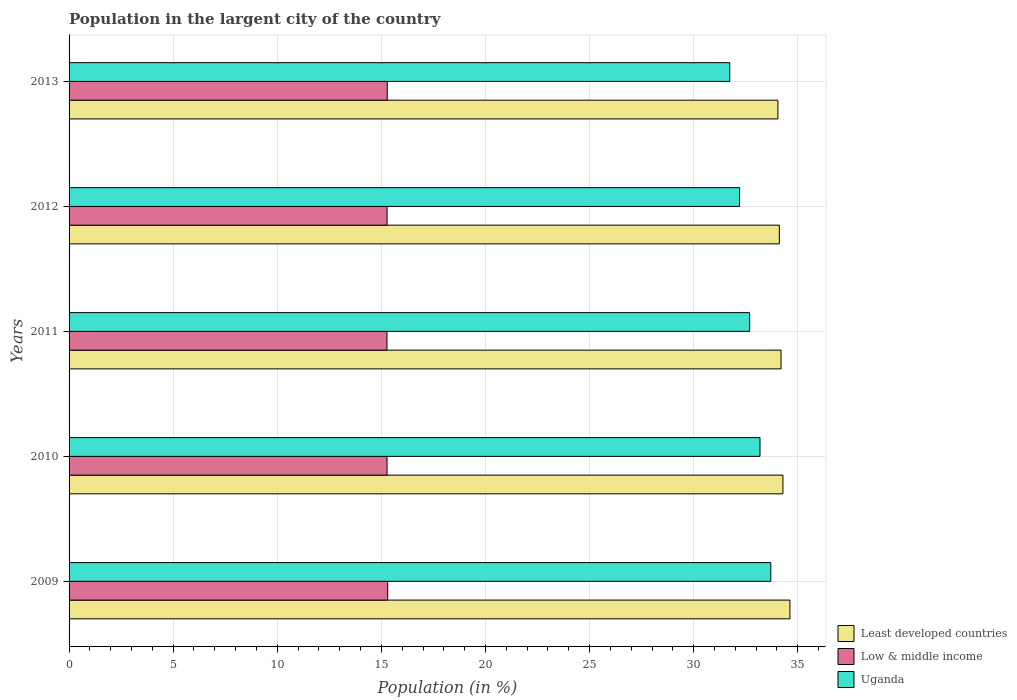How many groups of bars are there?
Offer a very short reply. 5. Are the number of bars per tick equal to the number of legend labels?
Offer a very short reply. Yes. How many bars are there on the 5th tick from the bottom?
Keep it short and to the point. 3. What is the percentage of population in the largent city in Uganda in 2011?
Provide a succinct answer. 32.69. Across all years, what is the maximum percentage of population in the largent city in Least developed countries?
Provide a succinct answer. 34.62. Across all years, what is the minimum percentage of population in the largent city in Uganda?
Ensure brevity in your answer.  31.73. In which year was the percentage of population in the largent city in Least developed countries minimum?
Your answer should be compact. 2013. What is the total percentage of population in the largent city in Least developed countries in the graph?
Your answer should be very brief. 171.27. What is the difference between the percentage of population in the largent city in Uganda in 2010 and that in 2011?
Provide a short and direct response. 0.5. What is the difference between the percentage of population in the largent city in Uganda in 2010 and the percentage of population in the largent city in Least developed countries in 2012?
Your answer should be compact. -0.93. What is the average percentage of population in the largent city in Uganda per year?
Provide a short and direct response. 32.7. In the year 2009, what is the difference between the percentage of population in the largent city in Uganda and percentage of population in the largent city in Least developed countries?
Offer a very short reply. -0.92. In how many years, is the percentage of population in the largent city in Least developed countries greater than 34 %?
Offer a terse response. 5. What is the ratio of the percentage of population in the largent city in Low & middle income in 2012 to that in 2013?
Provide a short and direct response. 1. What is the difference between the highest and the second highest percentage of population in the largent city in Uganda?
Ensure brevity in your answer.  0.52. What is the difference between the highest and the lowest percentage of population in the largent city in Least developed countries?
Give a very brief answer. 0.58. What does the 2nd bar from the top in 2010 represents?
Make the answer very short. Low & middle income. What does the 2nd bar from the bottom in 2011 represents?
Make the answer very short. Low & middle income. Is it the case that in every year, the sum of the percentage of population in the largent city in Low & middle income and percentage of population in the largent city in Uganda is greater than the percentage of population in the largent city in Least developed countries?
Your answer should be very brief. Yes. Are all the bars in the graph horizontal?
Your response must be concise. Yes. What is the difference between two consecutive major ticks on the X-axis?
Your response must be concise. 5. Are the values on the major ticks of X-axis written in scientific E-notation?
Make the answer very short. No. Does the graph contain grids?
Ensure brevity in your answer.  Yes. How many legend labels are there?
Provide a short and direct response. 3. How are the legend labels stacked?
Your response must be concise. Vertical. What is the title of the graph?
Ensure brevity in your answer.  Population in the largent city of the country. Does "Gambia, The" appear as one of the legend labels in the graph?
Your answer should be compact. No. What is the label or title of the Y-axis?
Make the answer very short. Years. What is the Population (in %) of Least developed countries in 2009?
Your answer should be compact. 34.62. What is the Population (in %) in Low & middle income in 2009?
Your answer should be very brief. 15.31. What is the Population (in %) of Uganda in 2009?
Offer a terse response. 33.71. What is the Population (in %) in Least developed countries in 2010?
Provide a succinct answer. 34.29. What is the Population (in %) of Low & middle income in 2010?
Offer a terse response. 15.27. What is the Population (in %) of Uganda in 2010?
Provide a succinct answer. 33.19. What is the Population (in %) in Least developed countries in 2011?
Your answer should be compact. 34.2. What is the Population (in %) of Low & middle income in 2011?
Your answer should be compact. 15.27. What is the Population (in %) of Uganda in 2011?
Make the answer very short. 32.69. What is the Population (in %) in Least developed countries in 2012?
Your response must be concise. 34.12. What is the Population (in %) in Low & middle income in 2012?
Ensure brevity in your answer.  15.27. What is the Population (in %) in Uganda in 2012?
Make the answer very short. 32.21. What is the Population (in %) in Least developed countries in 2013?
Your answer should be very brief. 34.05. What is the Population (in %) in Low & middle income in 2013?
Your response must be concise. 15.28. What is the Population (in %) in Uganda in 2013?
Make the answer very short. 31.73. Across all years, what is the maximum Population (in %) in Least developed countries?
Offer a terse response. 34.62. Across all years, what is the maximum Population (in %) in Low & middle income?
Offer a terse response. 15.31. Across all years, what is the maximum Population (in %) in Uganda?
Provide a succinct answer. 33.71. Across all years, what is the minimum Population (in %) in Least developed countries?
Your answer should be compact. 34.05. Across all years, what is the minimum Population (in %) of Low & middle income?
Ensure brevity in your answer.  15.27. Across all years, what is the minimum Population (in %) of Uganda?
Give a very brief answer. 31.73. What is the total Population (in %) in Least developed countries in the graph?
Your answer should be compact. 171.27. What is the total Population (in %) of Low & middle income in the graph?
Provide a succinct answer. 76.4. What is the total Population (in %) in Uganda in the graph?
Offer a terse response. 163.52. What is the difference between the Population (in %) of Least developed countries in 2009 and that in 2010?
Your answer should be very brief. 0.34. What is the difference between the Population (in %) of Low & middle income in 2009 and that in 2010?
Provide a short and direct response. 0.03. What is the difference between the Population (in %) in Uganda in 2009 and that in 2010?
Make the answer very short. 0.52. What is the difference between the Population (in %) in Least developed countries in 2009 and that in 2011?
Your answer should be very brief. 0.43. What is the difference between the Population (in %) in Low & middle income in 2009 and that in 2011?
Give a very brief answer. 0.04. What is the difference between the Population (in %) of Uganda in 2009 and that in 2011?
Offer a very short reply. 1.02. What is the difference between the Population (in %) of Least developed countries in 2009 and that in 2012?
Your answer should be very brief. 0.51. What is the difference between the Population (in %) of Low & middle income in 2009 and that in 2012?
Provide a short and direct response. 0.03. What is the difference between the Population (in %) in Uganda in 2009 and that in 2012?
Give a very brief answer. 1.5. What is the difference between the Population (in %) of Least developed countries in 2009 and that in 2013?
Your response must be concise. 0.58. What is the difference between the Population (in %) in Low & middle income in 2009 and that in 2013?
Your response must be concise. 0.02. What is the difference between the Population (in %) in Uganda in 2009 and that in 2013?
Provide a short and direct response. 1.97. What is the difference between the Population (in %) of Least developed countries in 2010 and that in 2011?
Offer a very short reply. 0.09. What is the difference between the Population (in %) in Low & middle income in 2010 and that in 2011?
Your answer should be very brief. 0. What is the difference between the Population (in %) in Uganda in 2010 and that in 2011?
Make the answer very short. 0.5. What is the difference between the Population (in %) of Least developed countries in 2010 and that in 2012?
Keep it short and to the point. 0.17. What is the difference between the Population (in %) in Low & middle income in 2010 and that in 2012?
Give a very brief answer. -0. What is the difference between the Population (in %) in Uganda in 2010 and that in 2012?
Keep it short and to the point. 0.98. What is the difference between the Population (in %) in Least developed countries in 2010 and that in 2013?
Provide a short and direct response. 0.24. What is the difference between the Population (in %) in Low & middle income in 2010 and that in 2013?
Ensure brevity in your answer.  -0.01. What is the difference between the Population (in %) of Uganda in 2010 and that in 2013?
Provide a short and direct response. 1.45. What is the difference between the Population (in %) in Least developed countries in 2011 and that in 2012?
Provide a succinct answer. 0.08. What is the difference between the Population (in %) in Low & middle income in 2011 and that in 2012?
Offer a very short reply. -0. What is the difference between the Population (in %) of Uganda in 2011 and that in 2012?
Ensure brevity in your answer.  0.48. What is the difference between the Population (in %) in Least developed countries in 2011 and that in 2013?
Your answer should be compact. 0.15. What is the difference between the Population (in %) of Low & middle income in 2011 and that in 2013?
Make the answer very short. -0.01. What is the difference between the Population (in %) in Uganda in 2011 and that in 2013?
Your answer should be very brief. 0.96. What is the difference between the Population (in %) in Least developed countries in 2012 and that in 2013?
Your response must be concise. 0.07. What is the difference between the Population (in %) of Low & middle income in 2012 and that in 2013?
Offer a very short reply. -0.01. What is the difference between the Population (in %) of Uganda in 2012 and that in 2013?
Your response must be concise. 0.47. What is the difference between the Population (in %) of Least developed countries in 2009 and the Population (in %) of Low & middle income in 2010?
Give a very brief answer. 19.35. What is the difference between the Population (in %) of Least developed countries in 2009 and the Population (in %) of Uganda in 2010?
Your response must be concise. 1.44. What is the difference between the Population (in %) in Low & middle income in 2009 and the Population (in %) in Uganda in 2010?
Provide a succinct answer. -17.88. What is the difference between the Population (in %) in Least developed countries in 2009 and the Population (in %) in Low & middle income in 2011?
Ensure brevity in your answer.  19.36. What is the difference between the Population (in %) in Least developed countries in 2009 and the Population (in %) in Uganda in 2011?
Provide a succinct answer. 1.94. What is the difference between the Population (in %) in Low & middle income in 2009 and the Population (in %) in Uganda in 2011?
Your response must be concise. -17.38. What is the difference between the Population (in %) of Least developed countries in 2009 and the Population (in %) of Low & middle income in 2012?
Offer a terse response. 19.35. What is the difference between the Population (in %) of Least developed countries in 2009 and the Population (in %) of Uganda in 2012?
Offer a terse response. 2.42. What is the difference between the Population (in %) of Low & middle income in 2009 and the Population (in %) of Uganda in 2012?
Offer a terse response. -16.9. What is the difference between the Population (in %) of Least developed countries in 2009 and the Population (in %) of Low & middle income in 2013?
Provide a succinct answer. 19.34. What is the difference between the Population (in %) of Least developed countries in 2009 and the Population (in %) of Uganda in 2013?
Offer a terse response. 2.89. What is the difference between the Population (in %) of Low & middle income in 2009 and the Population (in %) of Uganda in 2013?
Keep it short and to the point. -16.43. What is the difference between the Population (in %) in Least developed countries in 2010 and the Population (in %) in Low & middle income in 2011?
Offer a very short reply. 19.02. What is the difference between the Population (in %) in Least developed countries in 2010 and the Population (in %) in Uganda in 2011?
Give a very brief answer. 1.6. What is the difference between the Population (in %) in Low & middle income in 2010 and the Population (in %) in Uganda in 2011?
Provide a short and direct response. -17.42. What is the difference between the Population (in %) in Least developed countries in 2010 and the Population (in %) in Low & middle income in 2012?
Give a very brief answer. 19.02. What is the difference between the Population (in %) in Least developed countries in 2010 and the Population (in %) in Uganda in 2012?
Make the answer very short. 2.08. What is the difference between the Population (in %) in Low & middle income in 2010 and the Population (in %) in Uganda in 2012?
Offer a very short reply. -16.93. What is the difference between the Population (in %) in Least developed countries in 2010 and the Population (in %) in Low & middle income in 2013?
Provide a short and direct response. 19.01. What is the difference between the Population (in %) in Least developed countries in 2010 and the Population (in %) in Uganda in 2013?
Provide a short and direct response. 2.55. What is the difference between the Population (in %) of Low & middle income in 2010 and the Population (in %) of Uganda in 2013?
Keep it short and to the point. -16.46. What is the difference between the Population (in %) in Least developed countries in 2011 and the Population (in %) in Low & middle income in 2012?
Provide a succinct answer. 18.92. What is the difference between the Population (in %) of Least developed countries in 2011 and the Population (in %) of Uganda in 2012?
Keep it short and to the point. 1.99. What is the difference between the Population (in %) in Low & middle income in 2011 and the Population (in %) in Uganda in 2012?
Keep it short and to the point. -16.94. What is the difference between the Population (in %) of Least developed countries in 2011 and the Population (in %) of Low & middle income in 2013?
Make the answer very short. 18.91. What is the difference between the Population (in %) of Least developed countries in 2011 and the Population (in %) of Uganda in 2013?
Make the answer very short. 2.46. What is the difference between the Population (in %) of Low & middle income in 2011 and the Population (in %) of Uganda in 2013?
Provide a short and direct response. -16.47. What is the difference between the Population (in %) of Least developed countries in 2012 and the Population (in %) of Low & middle income in 2013?
Offer a terse response. 18.83. What is the difference between the Population (in %) in Least developed countries in 2012 and the Population (in %) in Uganda in 2013?
Keep it short and to the point. 2.38. What is the difference between the Population (in %) in Low & middle income in 2012 and the Population (in %) in Uganda in 2013?
Offer a very short reply. -16.46. What is the average Population (in %) of Least developed countries per year?
Your response must be concise. 34.25. What is the average Population (in %) of Low & middle income per year?
Offer a very short reply. 15.28. What is the average Population (in %) in Uganda per year?
Your answer should be compact. 32.7. In the year 2009, what is the difference between the Population (in %) in Least developed countries and Population (in %) in Low & middle income?
Provide a short and direct response. 19.32. In the year 2009, what is the difference between the Population (in %) in Least developed countries and Population (in %) in Uganda?
Offer a very short reply. 0.92. In the year 2009, what is the difference between the Population (in %) of Low & middle income and Population (in %) of Uganda?
Your response must be concise. -18.4. In the year 2010, what is the difference between the Population (in %) in Least developed countries and Population (in %) in Low & middle income?
Make the answer very short. 19.02. In the year 2010, what is the difference between the Population (in %) in Least developed countries and Population (in %) in Uganda?
Provide a short and direct response. 1.1. In the year 2010, what is the difference between the Population (in %) in Low & middle income and Population (in %) in Uganda?
Offer a very short reply. -17.92. In the year 2011, what is the difference between the Population (in %) of Least developed countries and Population (in %) of Low & middle income?
Provide a succinct answer. 18.93. In the year 2011, what is the difference between the Population (in %) of Least developed countries and Population (in %) of Uganda?
Your answer should be very brief. 1.51. In the year 2011, what is the difference between the Population (in %) in Low & middle income and Population (in %) in Uganda?
Keep it short and to the point. -17.42. In the year 2012, what is the difference between the Population (in %) in Least developed countries and Population (in %) in Low & middle income?
Make the answer very short. 18.84. In the year 2012, what is the difference between the Population (in %) in Least developed countries and Population (in %) in Uganda?
Your answer should be very brief. 1.91. In the year 2012, what is the difference between the Population (in %) of Low & middle income and Population (in %) of Uganda?
Your response must be concise. -16.93. In the year 2013, what is the difference between the Population (in %) of Least developed countries and Population (in %) of Low & middle income?
Ensure brevity in your answer.  18.76. In the year 2013, what is the difference between the Population (in %) of Least developed countries and Population (in %) of Uganda?
Your response must be concise. 2.31. In the year 2013, what is the difference between the Population (in %) in Low & middle income and Population (in %) in Uganda?
Your answer should be very brief. -16.45. What is the ratio of the Population (in %) of Least developed countries in 2009 to that in 2010?
Your answer should be compact. 1.01. What is the ratio of the Population (in %) of Uganda in 2009 to that in 2010?
Provide a short and direct response. 1.02. What is the ratio of the Population (in %) in Least developed countries in 2009 to that in 2011?
Offer a terse response. 1.01. What is the ratio of the Population (in %) in Uganda in 2009 to that in 2011?
Your answer should be very brief. 1.03. What is the ratio of the Population (in %) of Least developed countries in 2009 to that in 2012?
Offer a very short reply. 1.01. What is the ratio of the Population (in %) in Uganda in 2009 to that in 2012?
Your answer should be very brief. 1.05. What is the ratio of the Population (in %) of Least developed countries in 2009 to that in 2013?
Give a very brief answer. 1.02. What is the ratio of the Population (in %) in Low & middle income in 2009 to that in 2013?
Your response must be concise. 1. What is the ratio of the Population (in %) of Uganda in 2009 to that in 2013?
Your answer should be compact. 1.06. What is the ratio of the Population (in %) of Least developed countries in 2010 to that in 2011?
Offer a terse response. 1. What is the ratio of the Population (in %) of Uganda in 2010 to that in 2011?
Your answer should be compact. 1.02. What is the ratio of the Population (in %) of Least developed countries in 2010 to that in 2012?
Give a very brief answer. 1.01. What is the ratio of the Population (in %) of Uganda in 2010 to that in 2012?
Offer a terse response. 1.03. What is the ratio of the Population (in %) of Least developed countries in 2010 to that in 2013?
Ensure brevity in your answer.  1.01. What is the ratio of the Population (in %) in Low & middle income in 2010 to that in 2013?
Your answer should be compact. 1. What is the ratio of the Population (in %) in Uganda in 2010 to that in 2013?
Keep it short and to the point. 1.05. What is the ratio of the Population (in %) of Least developed countries in 2011 to that in 2012?
Keep it short and to the point. 1. What is the ratio of the Population (in %) of Low & middle income in 2011 to that in 2012?
Your answer should be compact. 1. What is the ratio of the Population (in %) in Low & middle income in 2011 to that in 2013?
Provide a succinct answer. 1. What is the ratio of the Population (in %) of Uganda in 2011 to that in 2013?
Your answer should be very brief. 1.03. What is the ratio of the Population (in %) of Low & middle income in 2012 to that in 2013?
Give a very brief answer. 1. What is the ratio of the Population (in %) of Uganda in 2012 to that in 2013?
Provide a succinct answer. 1.01. What is the difference between the highest and the second highest Population (in %) in Least developed countries?
Provide a succinct answer. 0.34. What is the difference between the highest and the second highest Population (in %) of Low & middle income?
Offer a very short reply. 0.02. What is the difference between the highest and the second highest Population (in %) of Uganda?
Your answer should be compact. 0.52. What is the difference between the highest and the lowest Population (in %) in Least developed countries?
Your response must be concise. 0.58. What is the difference between the highest and the lowest Population (in %) in Low & middle income?
Ensure brevity in your answer.  0.04. What is the difference between the highest and the lowest Population (in %) of Uganda?
Your answer should be compact. 1.97. 